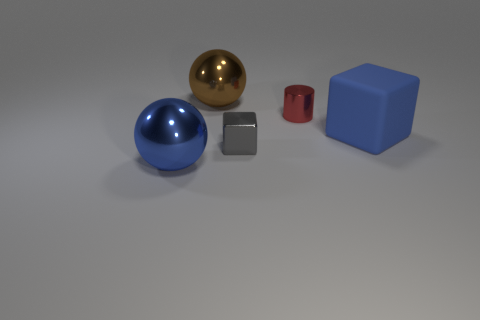Add 4 big spheres. How many objects exist? 9 Subtract all spheres. How many objects are left? 3 Add 3 tiny brown spheres. How many tiny brown spheres exist? 3 Subtract 0 gray cylinders. How many objects are left? 5 Subtract all small red matte balls. Subtract all big brown metal balls. How many objects are left? 4 Add 2 large rubber things. How many large rubber things are left? 3 